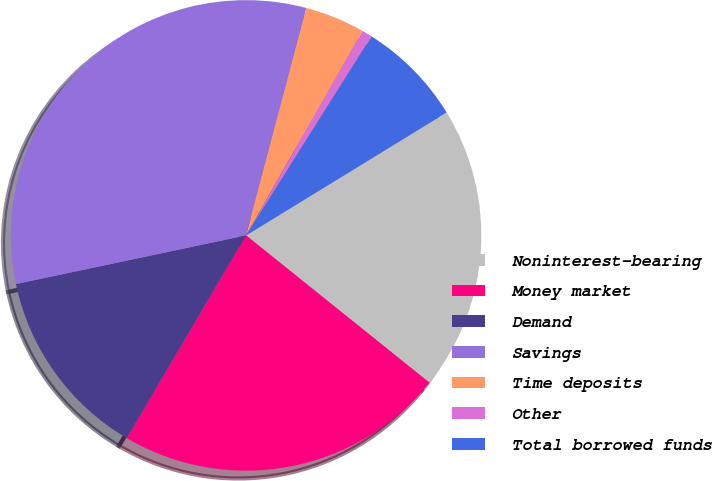<chart> <loc_0><loc_0><loc_500><loc_500><pie_chart><fcel>Noninterest-bearing<fcel>Money market<fcel>Demand<fcel>Savings<fcel>Time deposits<fcel>Other<fcel>Total borrowed funds<nl><fcel>19.52%<fcel>22.69%<fcel>13.22%<fcel>32.44%<fcel>4.12%<fcel>0.71%<fcel>7.29%<nl></chart> 